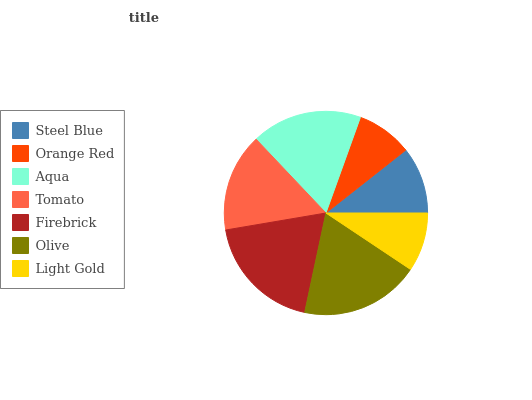Is Orange Red the minimum?
Answer yes or no. Yes. Is Olive the maximum?
Answer yes or no. Yes. Is Aqua the minimum?
Answer yes or no. No. Is Aqua the maximum?
Answer yes or no. No. Is Aqua greater than Orange Red?
Answer yes or no. Yes. Is Orange Red less than Aqua?
Answer yes or no. Yes. Is Orange Red greater than Aqua?
Answer yes or no. No. Is Aqua less than Orange Red?
Answer yes or no. No. Is Tomato the high median?
Answer yes or no. Yes. Is Tomato the low median?
Answer yes or no. Yes. Is Steel Blue the high median?
Answer yes or no. No. Is Firebrick the low median?
Answer yes or no. No. 